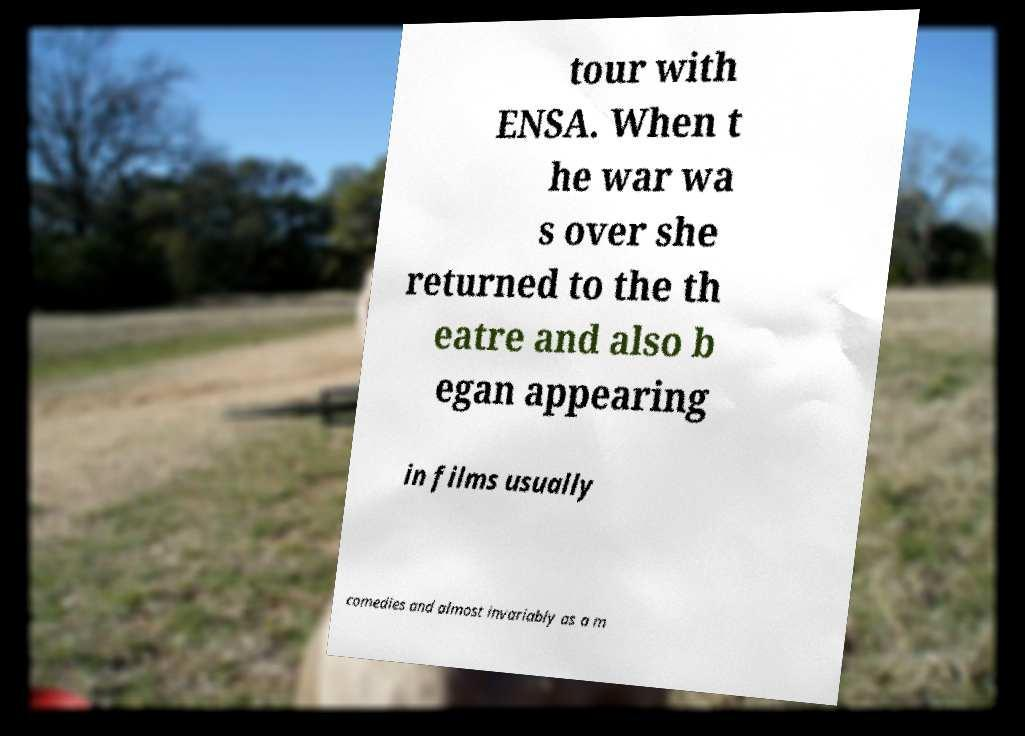Could you extract and type out the text from this image? tour with ENSA. When t he war wa s over she returned to the th eatre and also b egan appearing in films usually comedies and almost invariably as a m 